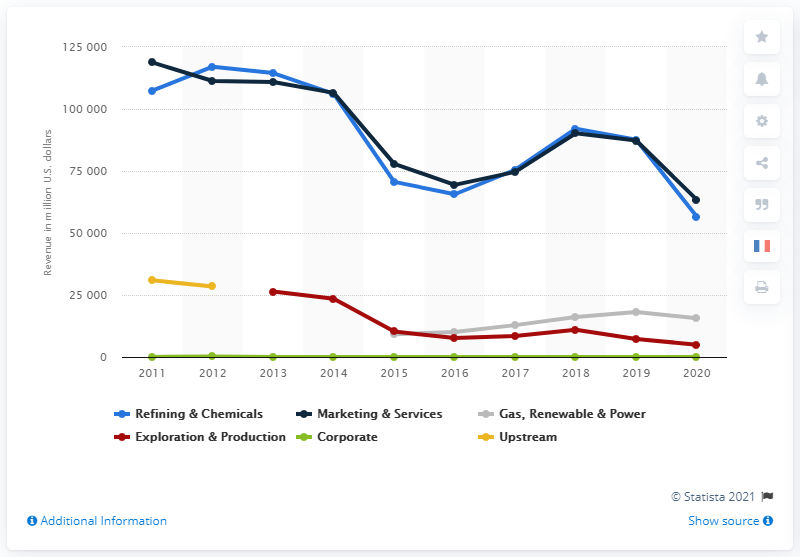Identify some key points in this picture. The Marketing & Services segment of Total SE generated 63,451 in non-Group sales in 2020. 